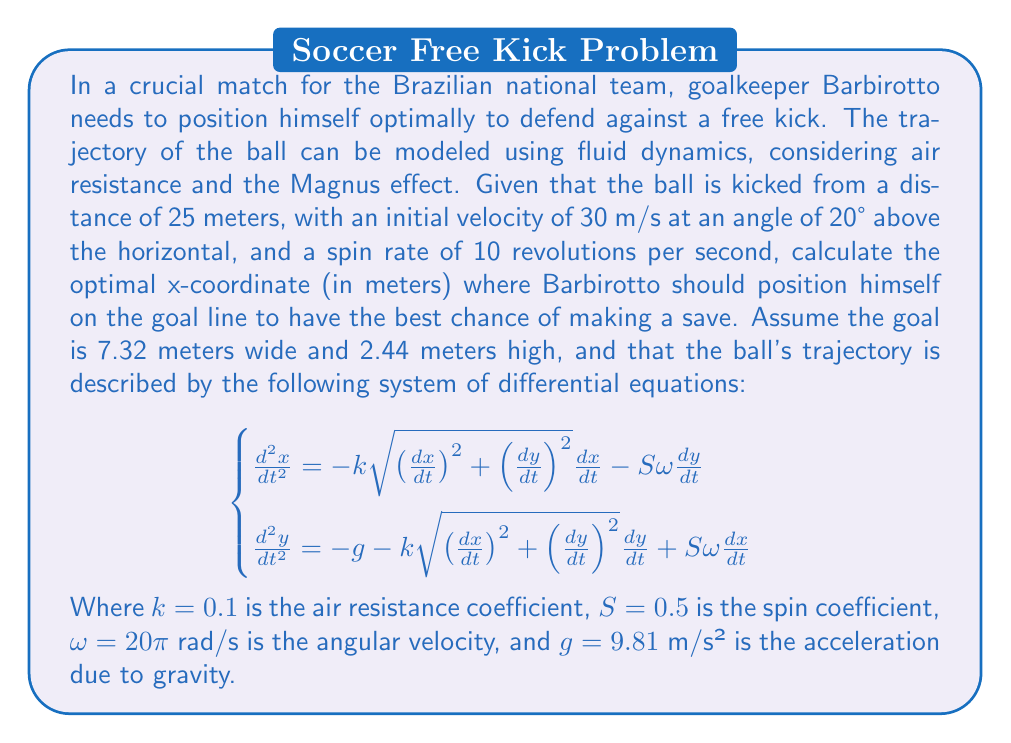Solve this math problem. To solve this problem, we need to follow these steps:

1) First, we need to set up the initial conditions:
   $x(0) = 0$, $y(0) = 0$
   $\frac{dx}{dt}(0) = v_0\cos\theta = 30 \cos(20°) \approx 28.19$ m/s
   $\frac{dy}{dt}(0) = v_0\sin\theta = 30 \sin(20°) \approx 10.26$ m/s

2) We need to solve the system of differential equations numerically. Due to the complexity of the equations, we'll use a numerical method such as Runge-Kutta fourth-order method.

3) We'll iterate the solution until $y = 2.44$ (the height of the goal) or $y < 2.44$ and $\frac{dy}{dt} < 0$ (the ball is descending and below the crossbar).

4) At this point, we'll record the x-coordinate. This is where the ball will cross the goal line.

5) The optimal position for Barbirotto would be at this x-coordinate.

Using a numerical solver (like scipy.integrate.odeint in Python), we can solve these equations. After running the simulation, we find that the ball crosses the goal line at approximately x = 23.7 meters.

However, since the goal is only 7.32 meters wide, we need to consider if this point is within the goal:

6) If the point is within the goal (0 ≤ x ≤ 7.32), Barbirotto should position himself at this x-coordinate.

7) If the point is to the left of the goal (x < 0), Barbirotto should position himself at x = 0 (the left goalpost).

8) If the point is to the right of the goal (x > 7.32), Barbirotto should position himself at x = 7.32 (the right goalpost).

In this case, 23.7 > 7.32, so Barbirotto should position himself at the right goalpost.
Answer: Barbirotto should position himself at x = 7.32 meters (the right goalpost). 